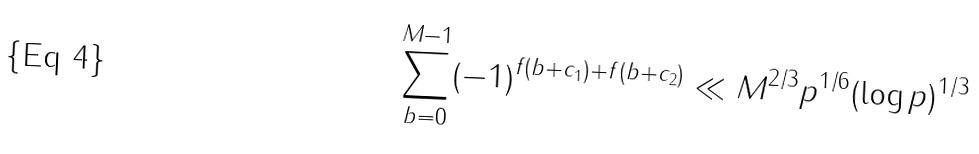<formula> <loc_0><loc_0><loc_500><loc_500>\sum _ { b = 0 } ^ { M - 1 } ( - 1 ) ^ { f ( b + c _ { 1 } ) + f ( b + c _ { 2 } ) } \ll M ^ { 2 / 3 } p ^ { 1 / 6 } ( \log p ) ^ { 1 / 3 }</formula> 